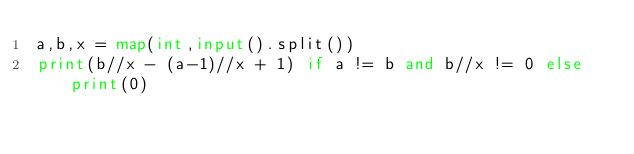Convert code to text. <code><loc_0><loc_0><loc_500><loc_500><_Python_>a,b,x = map(int,input().split())
print(b//x - (a-1)//x + 1) if a != b and b//x != 0 else print(0)</code> 